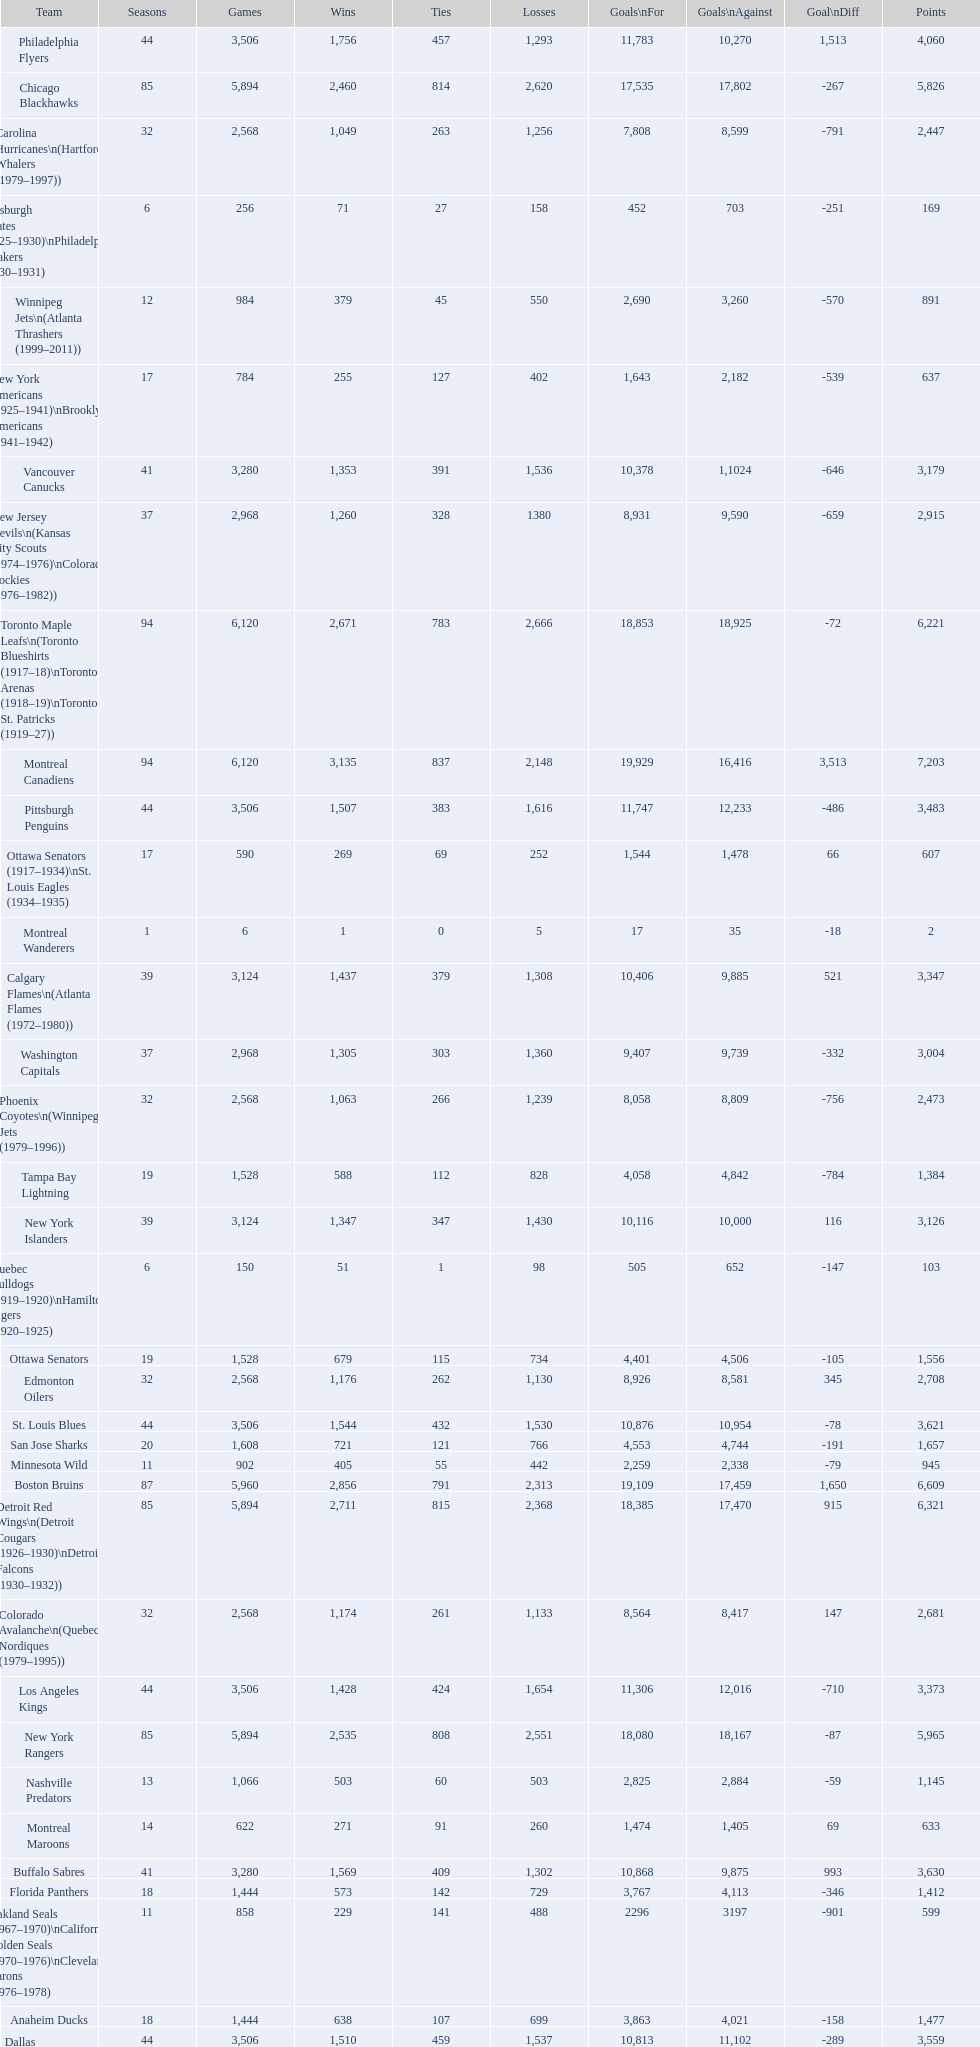Help me parse the entirety of this table. {'header': ['Team', 'Seasons', 'Games', 'Wins', 'Ties', 'Losses', 'Goals\\nFor', 'Goals\\nAgainst', 'Goal\\nDiff', 'Points'], 'rows': [['Philadelphia Flyers', '44', '3,506', '1,756', '457', '1,293', '11,783', '10,270', '1,513', '4,060'], ['Chicago Blackhawks', '85', '5,894', '2,460', '814', '2,620', '17,535', '17,802', '-267', '5,826'], ['Carolina Hurricanes\\n(Hartford Whalers (1979–1997))', '32', '2,568', '1,049', '263', '1,256', '7,808', '8,599', '-791', '2,447'], ['Pittsburgh Pirates (1925–1930)\\nPhiladelphia Quakers (1930–1931)', '6', '256', '71', '27', '158', '452', '703', '-251', '169'], ['Winnipeg Jets\\n(Atlanta Thrashers (1999–2011))', '12', '984', '379', '45', '550', '2,690', '3,260', '-570', '891'], ['New York Americans (1925–1941)\\nBrooklyn Americans (1941–1942)', '17', '784', '255', '127', '402', '1,643', '2,182', '-539', '637'], ['Vancouver Canucks', '41', '3,280', '1,353', '391', '1,536', '10,378', '1,1024', '-646', '3,179'], ['New Jersey Devils\\n(Kansas City Scouts (1974–1976)\\nColorado Rockies (1976–1982))', '37', '2,968', '1,260', '328', '1380', '8,931', '9,590', '-659', '2,915'], ['Toronto Maple Leafs\\n(Toronto Blueshirts (1917–18)\\nToronto Arenas (1918–19)\\nToronto St. Patricks (1919–27))', '94', '6,120', '2,671', '783', '2,666', '18,853', '18,925', '-72', '6,221'], ['Montreal Canadiens', '94', '6,120', '3,135', '837', '2,148', '19,929', '16,416', '3,513', '7,203'], ['Pittsburgh Penguins', '44', '3,506', '1,507', '383', '1,616', '11,747', '12,233', '-486', '3,483'], ['Ottawa Senators (1917–1934)\\nSt. Louis Eagles (1934–1935)', '17', '590', '269', '69', '252', '1,544', '1,478', '66', '607'], ['Montreal Wanderers', '1', '6', '1', '0', '5', '17', '35', '-18', '2'], ['Calgary Flames\\n(Atlanta Flames (1972–1980))', '39', '3,124', '1,437', '379', '1,308', '10,406', '9,885', '521', '3,347'], ['Washington Capitals', '37', '2,968', '1,305', '303', '1,360', '9,407', '9,739', '-332', '3,004'], ['Phoenix Coyotes\\n(Winnipeg Jets (1979–1996))', '32', '2,568', '1,063', '266', '1,239', '8,058', '8,809', '-756', '2,473'], ['Tampa Bay Lightning', '19', '1,528', '588', '112', '828', '4,058', '4,842', '-784', '1,384'], ['New York Islanders', '39', '3,124', '1,347', '347', '1,430', '10,116', '10,000', '116', '3,126'], ['Quebec Bulldogs (1919–1920)\\nHamilton Tigers (1920–1925)', '6', '150', '51', '1', '98', '505', '652', '-147', '103'], ['Ottawa Senators', '19', '1,528', '679', '115', '734', '4,401', '4,506', '-105', '1,556'], ['Edmonton Oilers', '32', '2,568', '1,176', '262', '1,130', '8,926', '8,581', '345', '2,708'], ['St. Louis Blues', '44', '3,506', '1,544', '432', '1,530', '10,876', '10,954', '-78', '3,621'], ['San Jose Sharks', '20', '1,608', '721', '121', '766', '4,553', '4,744', '-191', '1,657'], ['Minnesota Wild', '11', '902', '405', '55', '442', '2,259', '2,338', '-79', '945'], ['Boston Bruins', '87', '5,960', '2,856', '791', '2,313', '19,109', '17,459', '1,650', '6,609'], ['Detroit Red Wings\\n(Detroit Cougars (1926–1930)\\nDetroit Falcons (1930–1932))', '85', '5,894', '2,711', '815', '2,368', '18,385', '17,470', '915', '6,321'], ['Colorado Avalanche\\n(Quebec Nordiques (1979–1995))', '32', '2,568', '1,174', '261', '1,133', '8,564', '8,417', '147', '2,681'], ['Los Angeles Kings', '44', '3,506', '1,428', '424', '1,654', '11,306', '12,016', '-710', '3,373'], ['New York Rangers', '85', '5,894', '2,535', '808', '2,551', '18,080', '18,167', '-87', '5,965'], ['Nashville Predators', '13', '1,066', '503', '60', '503', '2,825', '2,884', '-59', '1,145'], ['Montreal Maroons', '14', '622', '271', '91', '260', '1,474', '1,405', '69', '633'], ['Buffalo Sabres', '41', '3,280', '1,569', '409', '1,302', '10,868', '9,875', '993', '3,630'], ['Florida Panthers', '18', '1,444', '573', '142', '729', '3,767', '4,113', '-346', '1,412'], ['Oakland Seals (1967–1970)\\nCalifornia Golden Seals (1970–1976)\\nCleveland Barons (1976–1978)', '11', '858', '229', '141', '488', '2296', '3197', '-901', '599'], ['Anaheim Ducks', '18', '1,444', '638', '107', '699', '3,863', '4,021', '-158', '1,477'], ['Dallas Stars\\n(Minnesota North Stars (1967–1993))', '44', '3,506', '1,510', '459', '1,537', '10,813', '11,102', '-289', '3,559'], ['Columbus Blue Jackets', '11', '902', '342', '33', '527', '2,220', '2,744', '-524', '803']]} How many losses do the st. louis blues have? 1,530. 